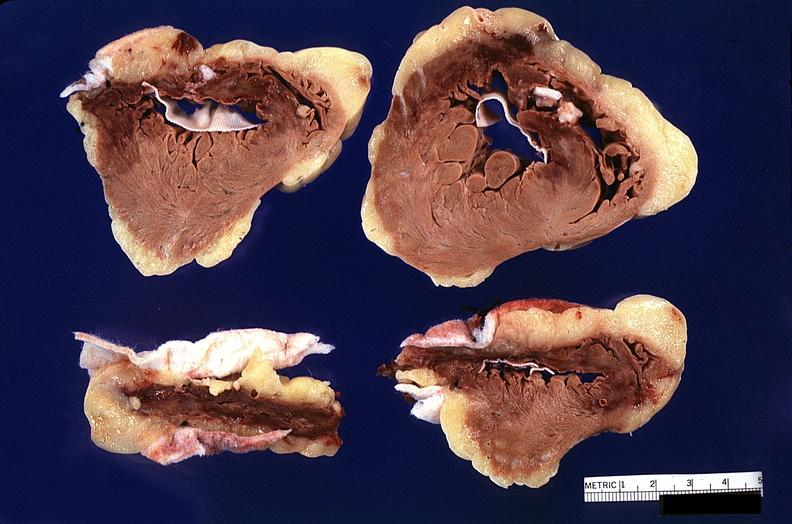what is present?
Answer the question using a single word or phrase. Cardiovascular 